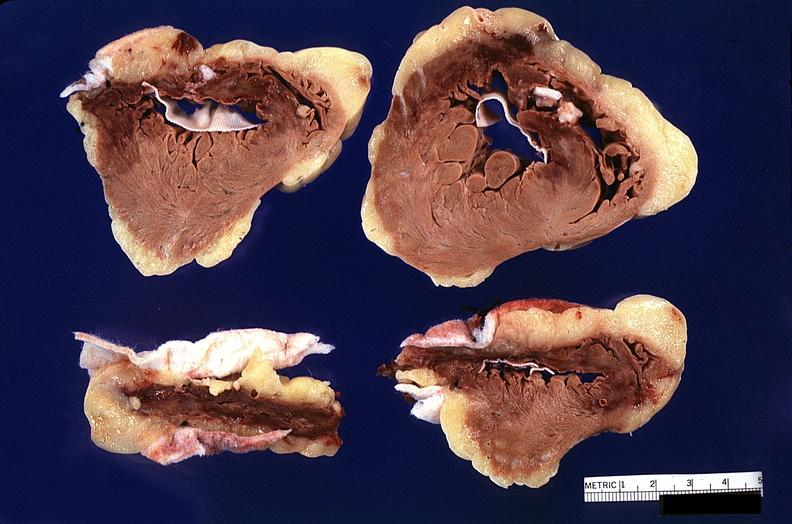what is present?
Answer the question using a single word or phrase. Cardiovascular 